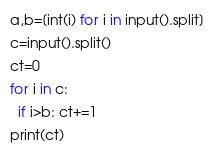<code> <loc_0><loc_0><loc_500><loc_500><_Python_>a,b=[int(i) for i in input().split]
c=input().split()
ct=0
for i in c:
  if i>b: ct+=1
print(ct)</code> 